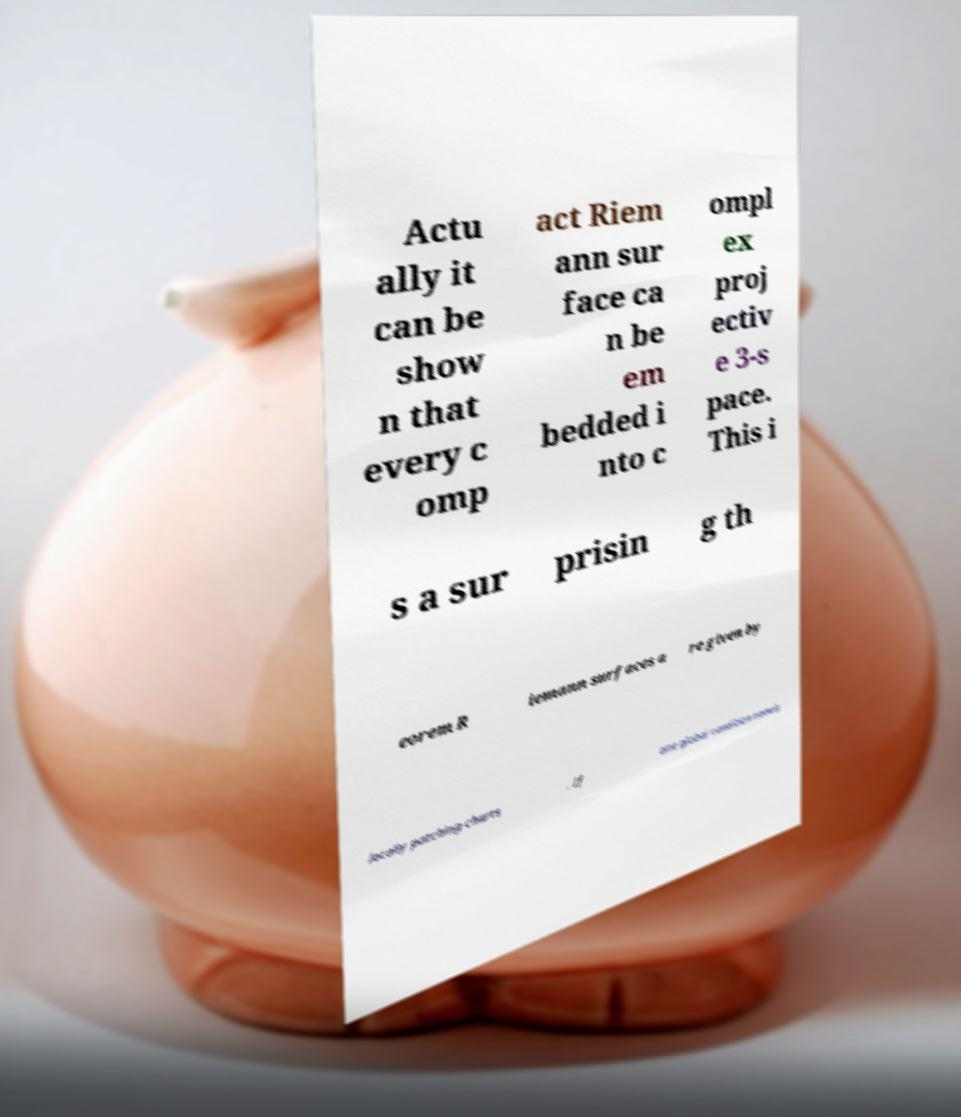I need the written content from this picture converted into text. Can you do that? Actu ally it can be show n that every c omp act Riem ann sur face ca n be em bedded i nto c ompl ex proj ectiv e 3-s pace. This i s a sur prisin g th eorem R iemann surfaces a re given by locally patching charts . If one global condition namely 